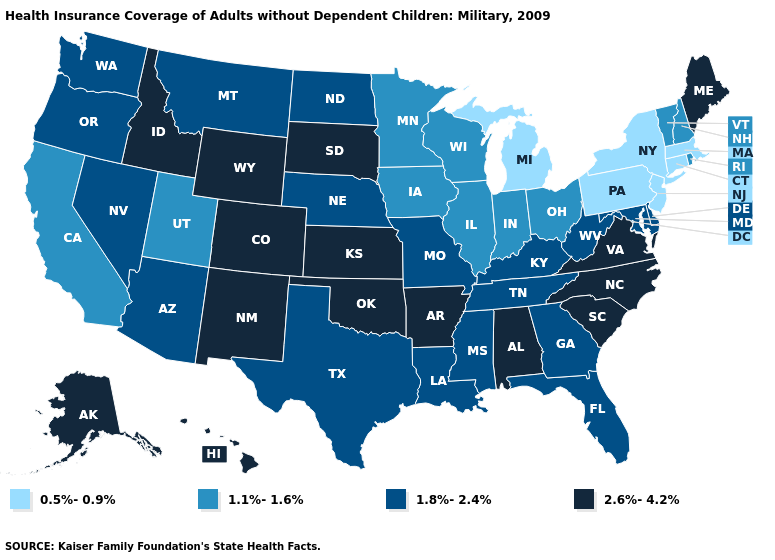What is the value of California?
Write a very short answer. 1.1%-1.6%. Name the states that have a value in the range 0.5%-0.9%?
Be succinct. Connecticut, Massachusetts, Michigan, New Jersey, New York, Pennsylvania. Which states have the highest value in the USA?
Short answer required. Alabama, Alaska, Arkansas, Colorado, Hawaii, Idaho, Kansas, Maine, New Mexico, North Carolina, Oklahoma, South Carolina, South Dakota, Virginia, Wyoming. Does Virginia have the highest value in the USA?
Give a very brief answer. Yes. Name the states that have a value in the range 1.8%-2.4%?
Write a very short answer. Arizona, Delaware, Florida, Georgia, Kentucky, Louisiana, Maryland, Mississippi, Missouri, Montana, Nebraska, Nevada, North Dakota, Oregon, Tennessee, Texas, Washington, West Virginia. What is the value of South Dakota?
Give a very brief answer. 2.6%-4.2%. What is the value of New Hampshire?
Write a very short answer. 1.1%-1.6%. Name the states that have a value in the range 1.8%-2.4%?
Short answer required. Arizona, Delaware, Florida, Georgia, Kentucky, Louisiana, Maryland, Mississippi, Missouri, Montana, Nebraska, Nevada, North Dakota, Oregon, Tennessee, Texas, Washington, West Virginia. Which states have the lowest value in the USA?
Answer briefly. Connecticut, Massachusetts, Michigan, New Jersey, New York, Pennsylvania. Does Georgia have the highest value in the USA?
Concise answer only. No. Name the states that have a value in the range 2.6%-4.2%?
Keep it brief. Alabama, Alaska, Arkansas, Colorado, Hawaii, Idaho, Kansas, Maine, New Mexico, North Carolina, Oklahoma, South Carolina, South Dakota, Virginia, Wyoming. Among the states that border South Carolina , which have the highest value?
Short answer required. North Carolina. What is the value of Indiana?
Quick response, please. 1.1%-1.6%. What is the value of Wyoming?
Concise answer only. 2.6%-4.2%. Does South Carolina have a higher value than Oregon?
Keep it brief. Yes. 